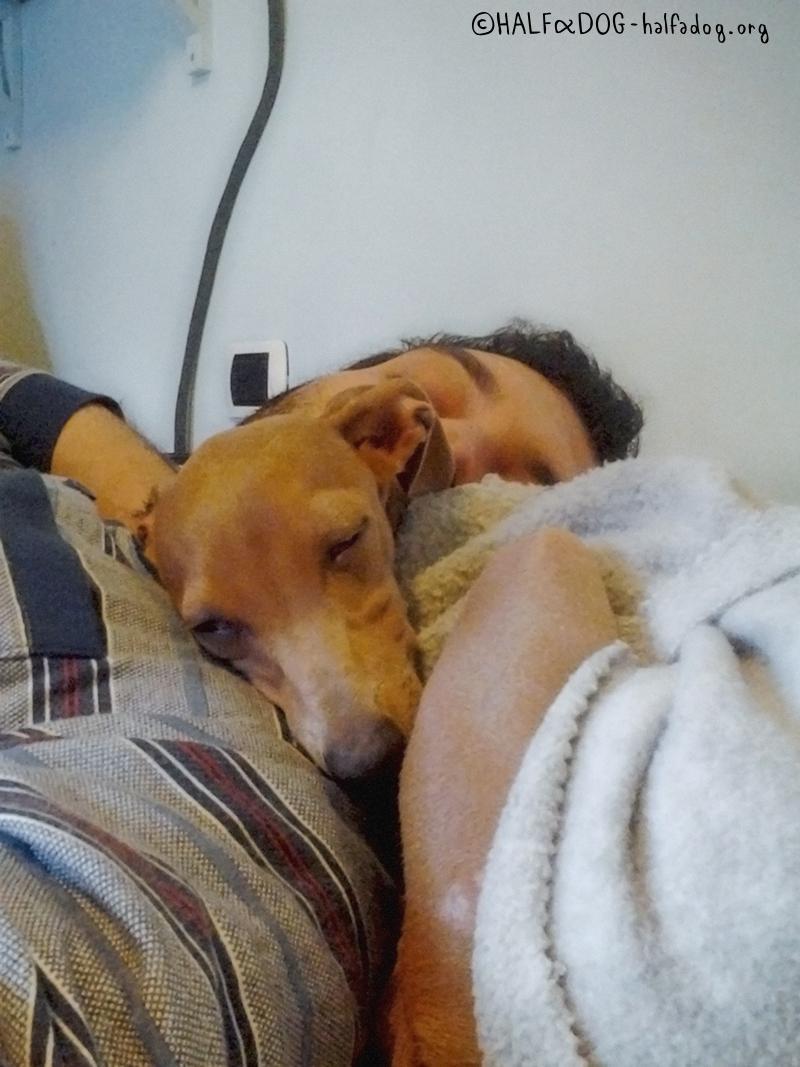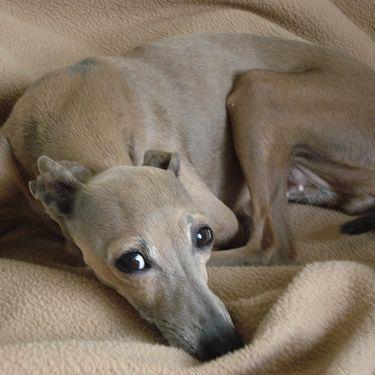The first image is the image on the left, the second image is the image on the right. Examine the images to the left and right. Is the description "There are a total of three dogs." accurate? Answer yes or no. No. The first image is the image on the left, the second image is the image on the right. Considering the images on both sides, is "A dog is sleeping with another dog in at least one picture." valid? Answer yes or no. No. 